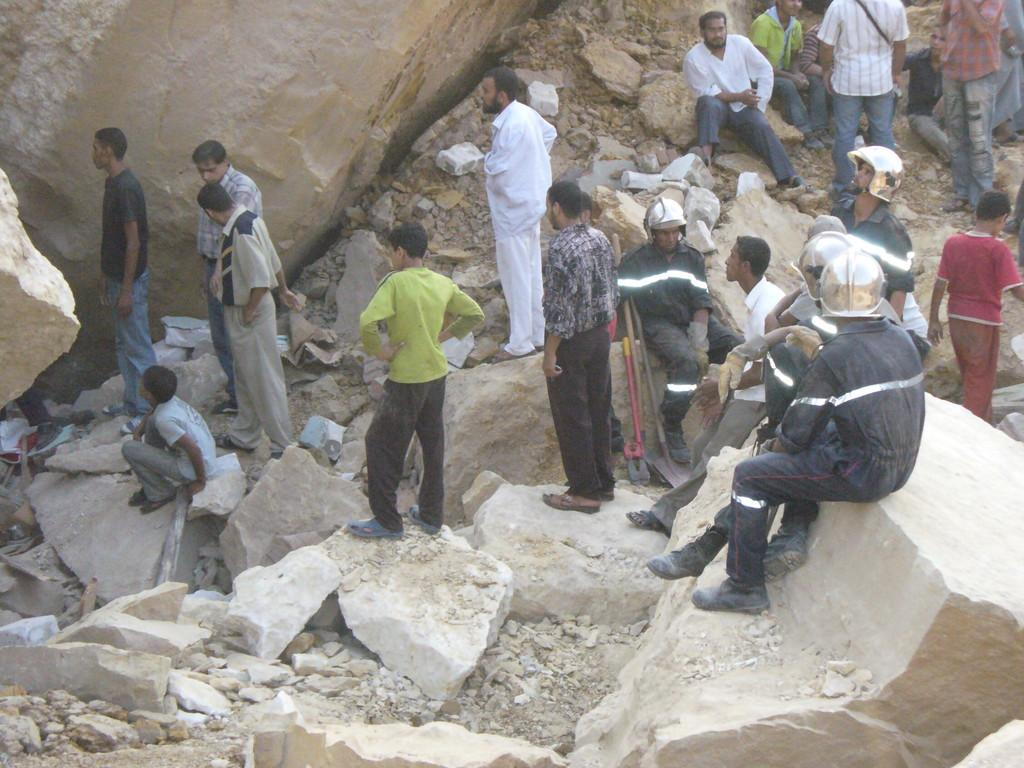What are the people in the image doing? There are people standing on the ground and sitting on rocks in the image. Can you describe the positions of the people in the image? Some people are standing, while others are sitting on rocks and other objects. How many light bulbs are visible in the image? There are no light bulbs present in the image. What type of stretching exercises are the people doing in the image? There is no indication of any stretching exercises being performed in the image. 